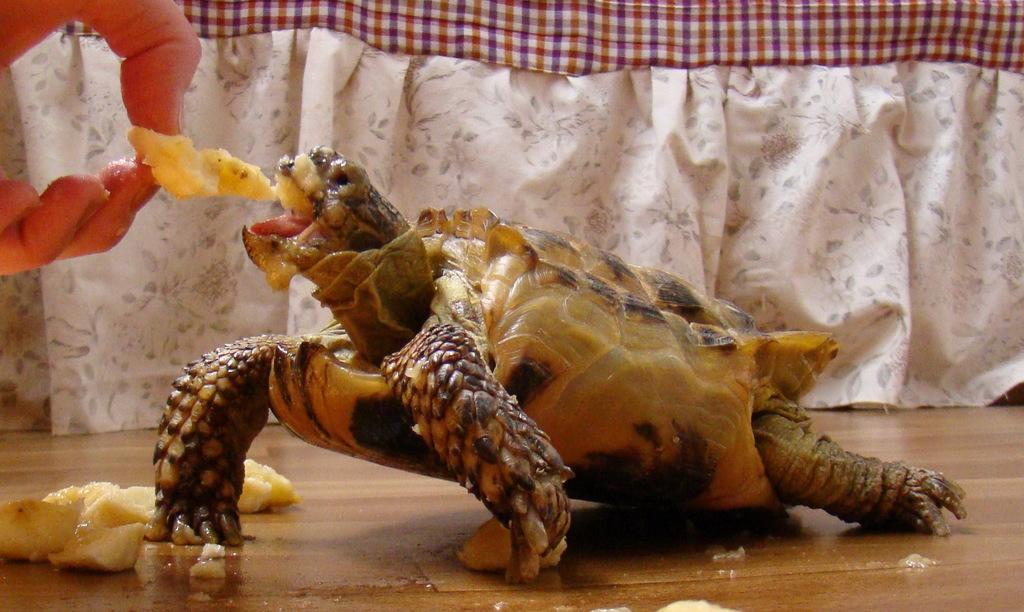Describe this image in one or two sentences. On the left we can see the hand of a person holding a food item and feeding a turtle standing on the ground and we can see there are some food items lying on the ground. In the background we can see the cloth. 